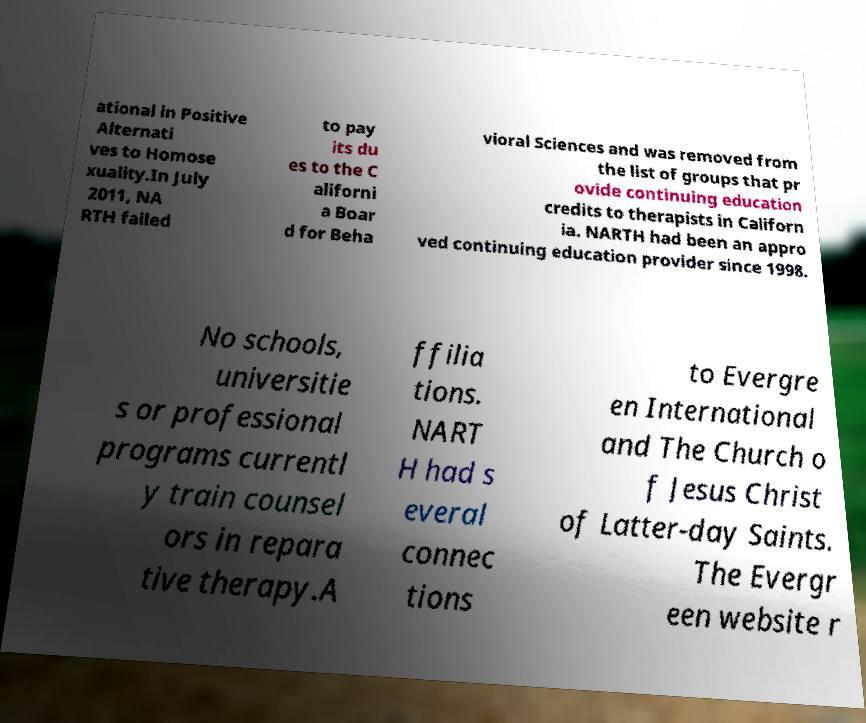Please identify and transcribe the text found in this image. ational in Positive Alternati ves to Homose xuality.In July 2011, NA RTH failed to pay its du es to the C aliforni a Boar d for Beha vioral Sciences and was removed from the list of groups that pr ovide continuing education credits to therapists in Californ ia. NARTH had been an appro ved continuing education provider since 1998. No schools, universitie s or professional programs currentl y train counsel ors in repara tive therapy.A ffilia tions. NART H had s everal connec tions to Evergre en International and The Church o f Jesus Christ of Latter-day Saints. The Evergr een website r 